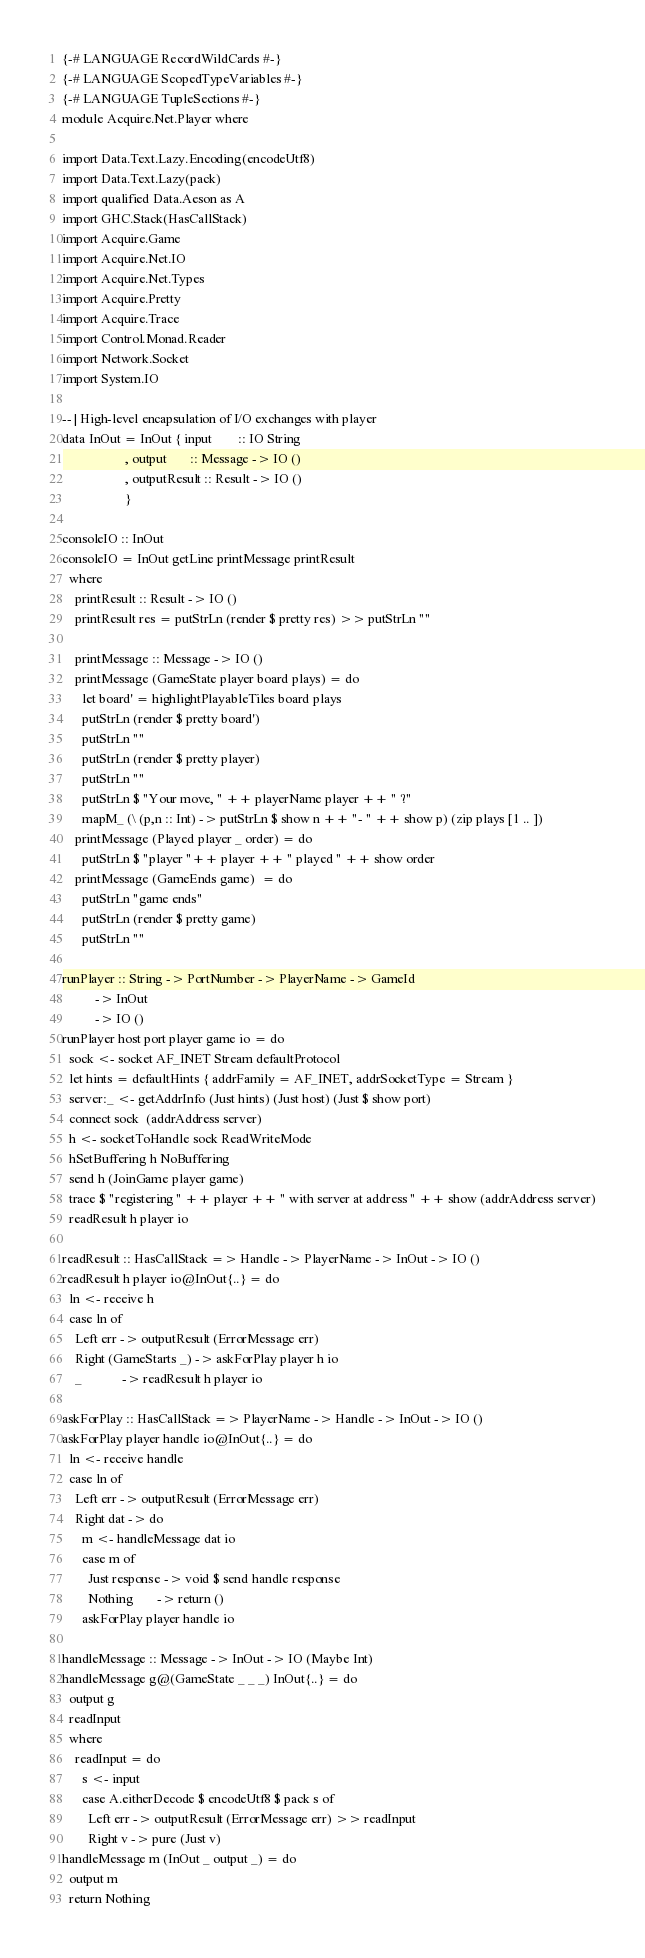<code> <loc_0><loc_0><loc_500><loc_500><_Haskell_>{-# LANGUAGE RecordWildCards #-}
{-# LANGUAGE ScopedTypeVariables #-}
{-# LANGUAGE TupleSections #-}
module Acquire.Net.Player where

import Data.Text.Lazy.Encoding(encodeUtf8)
import Data.Text.Lazy(pack)
import qualified Data.Aeson as A
import GHC.Stack(HasCallStack)
import Acquire.Game
import Acquire.Net.IO
import Acquire.Net.Types
import Acquire.Pretty
import Acquire.Trace
import Control.Monad.Reader
import Network.Socket
import System.IO

-- | High-level encapsulation of I/O exchanges with player
data InOut = InOut { input        :: IO String
                   , output       :: Message -> IO ()
                   , outputResult :: Result -> IO ()
                   }

consoleIO :: InOut
consoleIO = InOut getLine printMessage printResult
  where
    printResult :: Result -> IO ()
    printResult res = putStrLn (render $ pretty res) >> putStrLn ""

    printMessage :: Message -> IO ()
    printMessage (GameState player board plays) = do
      let board' = highlightPlayableTiles board plays
      putStrLn (render $ pretty board')
      putStrLn ""
      putStrLn (render $ pretty player)
      putStrLn ""
      putStrLn $ "Your move, " ++ playerName player ++ " ?"
      mapM_ (\ (p,n :: Int) -> putStrLn $ show n ++ "- " ++ show p) (zip plays [1 .. ])
    printMessage (Played player _ order) = do
      putStrLn $ "player "++ player ++ " played " ++ show order
    printMessage (GameEnds game)  = do
      putStrLn "game ends"
      putStrLn (render $ pretty game)
      putStrLn ""

runPlayer :: String -> PortNumber -> PlayerName -> GameId
          -> InOut
          -> IO ()
runPlayer host port player game io = do
  sock <- socket AF_INET Stream defaultProtocol
  let hints = defaultHints { addrFamily = AF_INET, addrSocketType = Stream }
  server:_ <- getAddrInfo (Just hints) (Just host) (Just $ show port)
  connect sock  (addrAddress server)
  h <- socketToHandle sock ReadWriteMode
  hSetBuffering h NoBuffering
  send h (JoinGame player game)
  trace $ "registering " ++ player ++ " with server at address " ++ show (addrAddress server)
  readResult h player io

readResult :: HasCallStack => Handle -> PlayerName -> InOut -> IO ()
readResult h player io@InOut{..} = do
  ln <- receive h
  case ln of
    Left err -> outputResult (ErrorMessage err)
    Right (GameStarts _) -> askForPlay player h io
    _            -> readResult h player io

askForPlay :: HasCallStack => PlayerName -> Handle -> InOut -> IO ()
askForPlay player handle io@InOut{..} = do
  ln <- receive handle
  case ln of
    Left err -> outputResult (ErrorMessage err)
    Right dat -> do
      m <- handleMessage dat io
      case m of
        Just response -> void $ send handle response
        Nothing       -> return ()
      askForPlay player handle io

handleMessage :: Message -> InOut -> IO (Maybe Int)
handleMessage g@(GameState _ _ _) InOut{..} = do
  output g
  readInput
  where
    readInput = do
      s <- input
      case A.eitherDecode $ encodeUtf8 $ pack s of
        Left err -> outputResult (ErrorMessage err) >> readInput
        Right v -> pure (Just v)
handleMessage m (InOut _ output _) = do
  output m
  return Nothing
</code> 